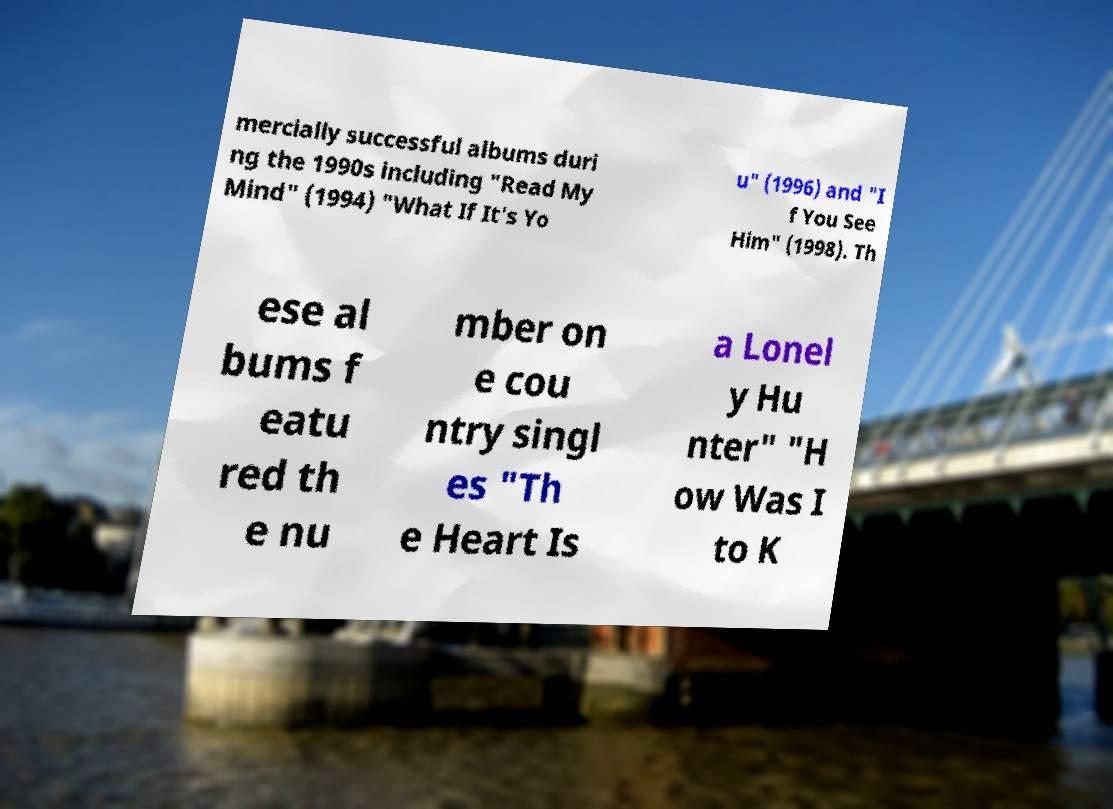Could you extract and type out the text from this image? mercially successful albums duri ng the 1990s including "Read My Mind" (1994) "What If It's Yo u" (1996) and "I f You See Him" (1998). Th ese al bums f eatu red th e nu mber on e cou ntry singl es "Th e Heart Is a Lonel y Hu nter" "H ow Was I to K 